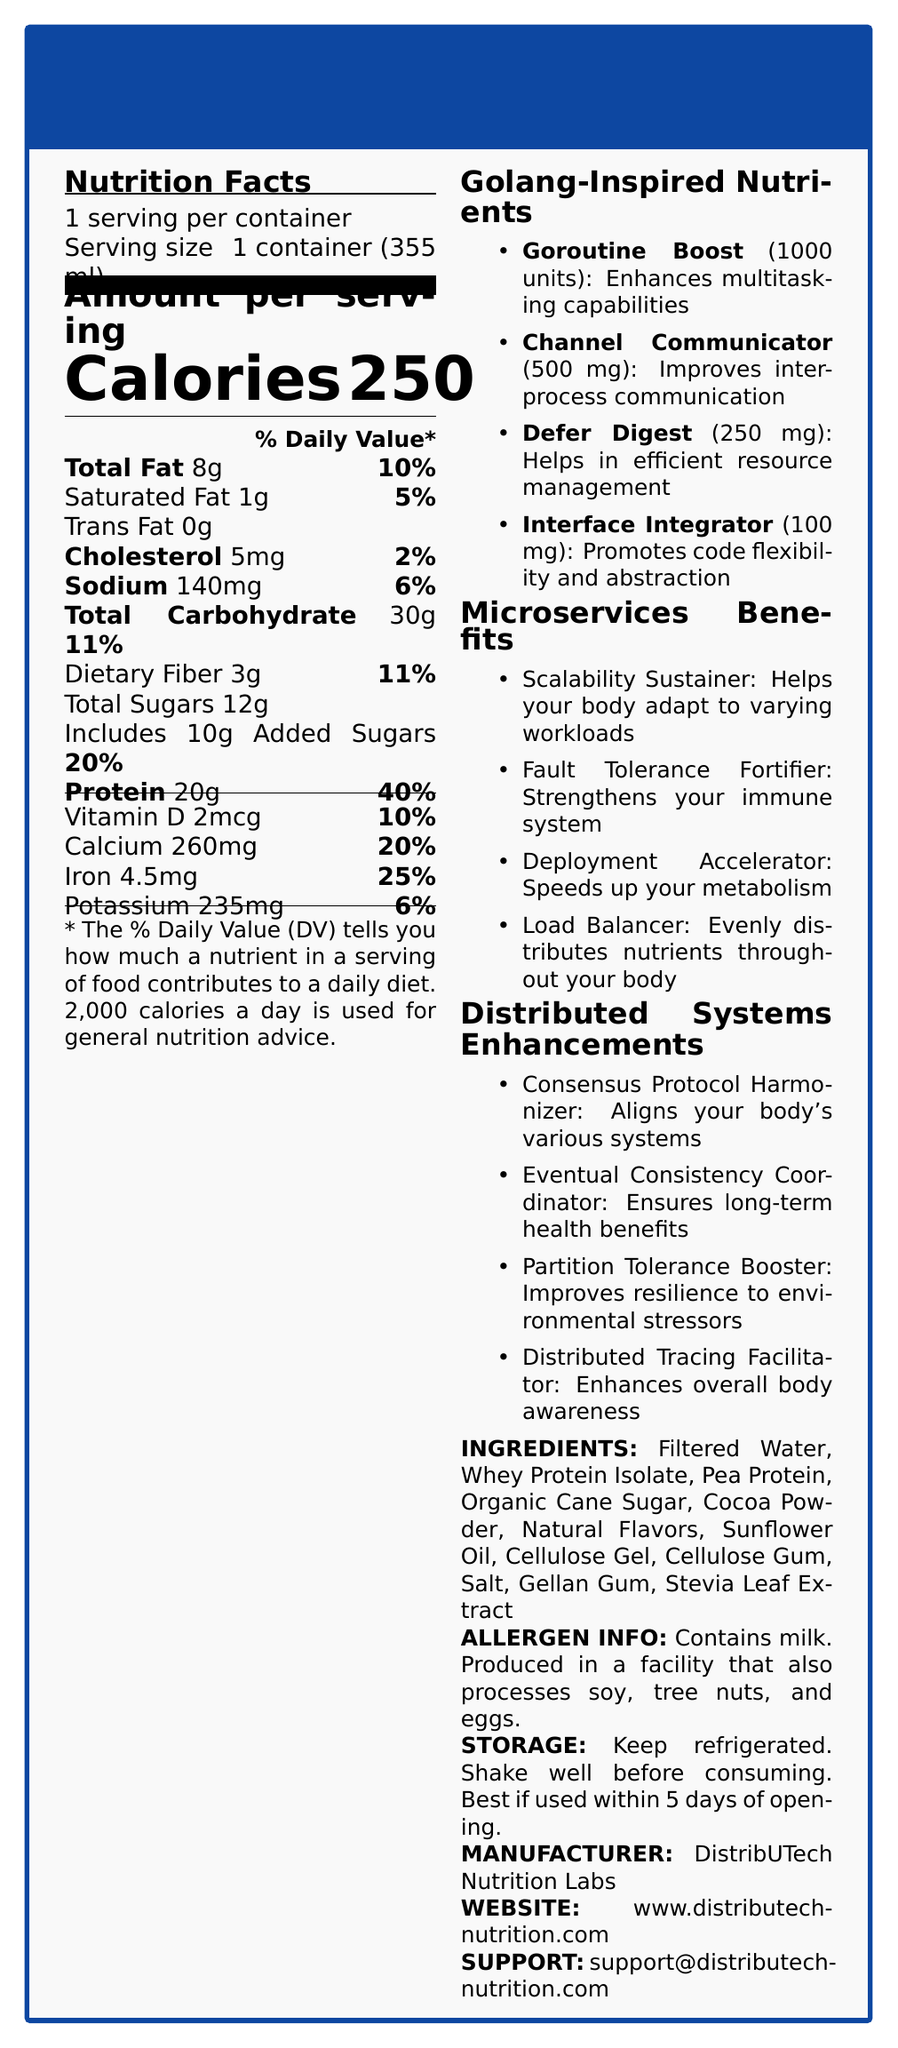how many servings are in one container? The document mentions "1 serving per container."
Answer: 1 what is the serving size of the Microservices Munchies: Distributed Nutrient Shake? The serving size is specified as "1 container (355 ml)."
Answer: 1 container (355 ml) how many calories does one serving contain? The document specifies "Calories: 250."
Answer: 250 which nutrient has the highest % Daily Value per serving? The document lists Protein with a % Daily Value of 40%, which is higher than other listed nutrients.
Answer: Protein how many grams of saturated fat are in one serving? The document lists "Saturated Fat 1g" under Total Fat.
Answer: 1g what are the ingredients of the shake? The document lists all these items under "INGREDIENTS."
Answer: Filtered Water, Whey Protein Isolate, Pea Protein, Organic Cane Sugar, Cocoa Powder, Natural Flavors, Sunflower Oil, Cellulose Gel, Cellulose Gum, Salt, Gellan Gum, Stevia Leaf Extract which vitamin is included at a 10% Daily Value? The document lists "Vitamin D 2mcg \hfill 10\%."
Answer: Vitamin D the shake contains which of the following allergens? A. Soy B. Tree Nuts C. Eggs D. Milk The document states "Contains milk" under ALLERGEN INFO.
Answer: D which of the following enhancements align with the concept of fault tolerance? I. Partition Tolerance Booster II. Fault Tolerance Fortifier III. Load Balancer Fault Tolerance Fortifier is explicitly named, and Partition Tolerance Booster also relates to fault tolerance.
Answer: I and II is the Microservices Munchies shake stored at room temperature? The document specifies under STORAGE: "Keep refrigerated. Shake well before consuming."
Answer: No how do "Interface Integrator" and "Channel Communicator" contribute to the shake's benefits? Both are specified under Golang-Inspired Nutrients with their respective benefits.
Answer: Interface Integrator promotes code flexibility and abstraction; Channel Communicator improves inter-process communication summarize the main idea of the document. The purpose of the document is to present detailed nutritional facts and unique features of the meal replacement shake, highlighting its benefits in terms of microservices and distributed systems.
Answer: The document provides comprehensive nutritional information about the "Microservices Munchies: Distributed Nutrient Shake." It includes serving size, calories, fat, carbohydrates, protein, vitamins, minerals, ingredients, allergen information, storage instructions, and additional benefits inspired by Golang and microservices themes. what is the amount of calcium in one serving? The document states "Calcium: 260mg" under Vitamins and Minerals.
Answer: 260mg who is the manufacturer of this product? The document specifies "DistribUTech Nutrition Labs" as the manufacturer.
Answer: DistribUTech Nutrition Labs how does the "Load Balancer" benefit the body? The Load Balancer benefit is explicitly listed in the document under Microservices Benefits.
Answer: Evenly distributes nutrients throughout your body is there information about the exact sugar types used in total sugars? The Total Carbohydrate section lists "Includes 10g Added Sugars" under Total Sugars.
Answer: Yes, it includes 10g Added Sugars how much "Goroutine Boost" does the shake contain? The document lists "Goroutine Boost (1000 units)" under Golang-Inspired Nutrients.
Answer: 1000 units does the shake provide more Dietary Fiber or Iron in terms of % Daily Value? Iron has a % Daily Value of 25%, while Dietary Fiber has 11%.
Answer: Iron can we determine the cost of the Microservices Munchies shake from the document? The document does not provide any information about the cost of the shake.
Answer: Cannot be determined 